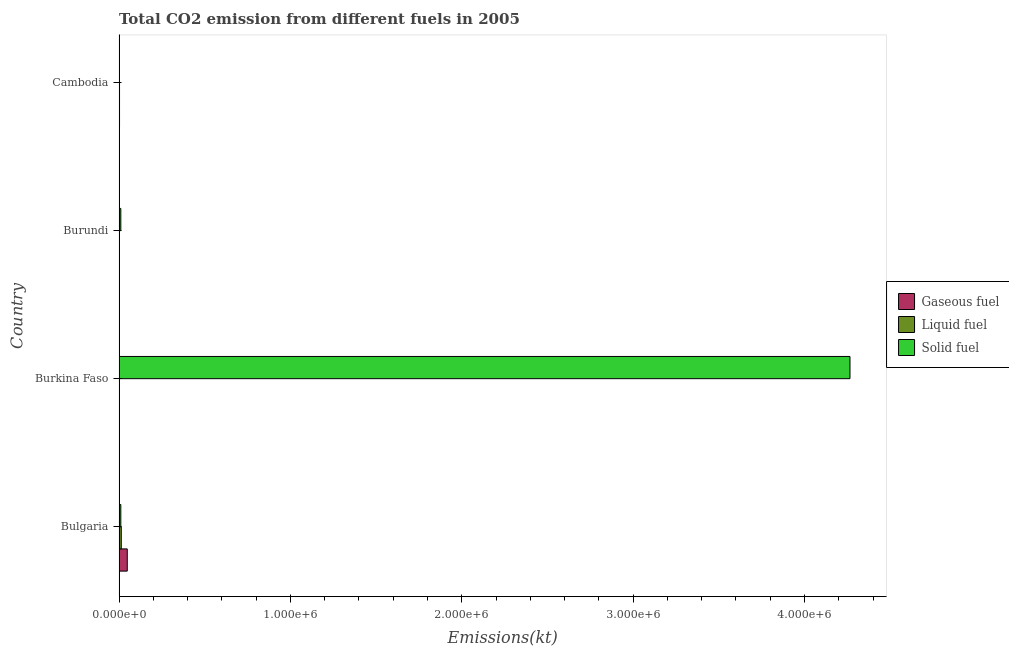How many groups of bars are there?
Your answer should be compact. 4. Are the number of bars per tick equal to the number of legend labels?
Offer a terse response. Yes. Are the number of bars on each tick of the Y-axis equal?
Your response must be concise. Yes. What is the label of the 3rd group of bars from the top?
Provide a short and direct response. Burkina Faso. What is the amount of co2 emissions from liquid fuel in Burundi?
Provide a short and direct response. 146.68. Across all countries, what is the maximum amount of co2 emissions from liquid fuel?
Make the answer very short. 1.29e+04. Across all countries, what is the minimum amount of co2 emissions from solid fuel?
Keep it short and to the point. 986.42. In which country was the amount of co2 emissions from liquid fuel maximum?
Keep it short and to the point. Bulgaria. In which country was the amount of co2 emissions from solid fuel minimum?
Ensure brevity in your answer.  Cambodia. What is the total amount of co2 emissions from gaseous fuel in the graph?
Your answer should be compact. 5.20e+04. What is the difference between the amount of co2 emissions from liquid fuel in Burundi and that in Cambodia?
Keep it short and to the point. -2629.24. What is the difference between the amount of co2 emissions from solid fuel in Burkina Faso and the amount of co2 emissions from gaseous fuel in Cambodia?
Provide a short and direct response. 4.26e+06. What is the average amount of co2 emissions from gaseous fuel per country?
Your answer should be very brief. 1.30e+04. What is the difference between the amount of co2 emissions from liquid fuel and amount of co2 emissions from solid fuel in Cambodia?
Ensure brevity in your answer.  1789.5. In how many countries, is the amount of co2 emissions from solid fuel greater than 2400000 kt?
Your answer should be compact. 1. What is the ratio of the amount of co2 emissions from liquid fuel in Burkina Faso to that in Burundi?
Your response must be concise. 7.58. Is the amount of co2 emissions from gaseous fuel in Bulgaria less than that in Burkina Faso?
Provide a succinct answer. No. Is the difference between the amount of co2 emissions from solid fuel in Burkina Faso and Burundi greater than the difference between the amount of co2 emissions from liquid fuel in Burkina Faso and Burundi?
Your answer should be very brief. Yes. What is the difference between the highest and the second highest amount of co2 emissions from liquid fuel?
Provide a short and direct response. 1.02e+04. What is the difference between the highest and the lowest amount of co2 emissions from solid fuel?
Provide a short and direct response. 4.26e+06. In how many countries, is the amount of co2 emissions from liquid fuel greater than the average amount of co2 emissions from liquid fuel taken over all countries?
Provide a succinct answer. 1. What does the 1st bar from the top in Burundi represents?
Your answer should be very brief. Solid fuel. What does the 1st bar from the bottom in Burkina Faso represents?
Keep it short and to the point. Gaseous fuel. Is it the case that in every country, the sum of the amount of co2 emissions from gaseous fuel and amount of co2 emissions from liquid fuel is greater than the amount of co2 emissions from solid fuel?
Ensure brevity in your answer.  No. How many bars are there?
Give a very brief answer. 12. Are all the bars in the graph horizontal?
Ensure brevity in your answer.  Yes. How many countries are there in the graph?
Provide a short and direct response. 4. What is the difference between two consecutive major ticks on the X-axis?
Ensure brevity in your answer.  1.00e+06. Are the values on the major ticks of X-axis written in scientific E-notation?
Your answer should be very brief. Yes. Where does the legend appear in the graph?
Provide a short and direct response. Center right. How many legend labels are there?
Your answer should be very brief. 3. What is the title of the graph?
Your answer should be very brief. Total CO2 emission from different fuels in 2005. Does "Ages 50+" appear as one of the legend labels in the graph?
Offer a terse response. No. What is the label or title of the X-axis?
Your response must be concise. Emissions(kt). What is the label or title of the Y-axis?
Your answer should be compact. Country. What is the Emissions(kt) of Gaseous fuel in Bulgaria?
Your response must be concise. 4.79e+04. What is the Emissions(kt) in Liquid fuel in Bulgaria?
Make the answer very short. 1.29e+04. What is the Emissions(kt) in Solid fuel in Bulgaria?
Provide a short and direct response. 1.03e+04. What is the Emissions(kt) of Gaseous fuel in Burkina Faso?
Your answer should be very brief. 1125.77. What is the Emissions(kt) in Liquid fuel in Burkina Faso?
Give a very brief answer. 1111.1. What is the Emissions(kt) of Solid fuel in Burkina Faso?
Provide a succinct answer. 4.27e+06. What is the Emissions(kt) in Gaseous fuel in Burundi?
Offer a very short reply. 154.01. What is the Emissions(kt) of Liquid fuel in Burundi?
Keep it short and to the point. 146.68. What is the Emissions(kt) in Solid fuel in Burundi?
Offer a terse response. 1.02e+04. What is the Emissions(kt) of Gaseous fuel in Cambodia?
Ensure brevity in your answer.  2775.92. What is the Emissions(kt) in Liquid fuel in Cambodia?
Your answer should be very brief. 2775.92. What is the Emissions(kt) in Solid fuel in Cambodia?
Offer a very short reply. 986.42. Across all countries, what is the maximum Emissions(kt) of Gaseous fuel?
Make the answer very short. 4.79e+04. Across all countries, what is the maximum Emissions(kt) of Liquid fuel?
Your response must be concise. 1.29e+04. Across all countries, what is the maximum Emissions(kt) in Solid fuel?
Your response must be concise. 4.27e+06. Across all countries, what is the minimum Emissions(kt) of Gaseous fuel?
Provide a short and direct response. 154.01. Across all countries, what is the minimum Emissions(kt) in Liquid fuel?
Provide a succinct answer. 146.68. Across all countries, what is the minimum Emissions(kt) of Solid fuel?
Your response must be concise. 986.42. What is the total Emissions(kt) of Gaseous fuel in the graph?
Keep it short and to the point. 5.20e+04. What is the total Emissions(kt) of Liquid fuel in the graph?
Provide a short and direct response. 1.70e+04. What is the total Emissions(kt) in Solid fuel in the graph?
Ensure brevity in your answer.  4.29e+06. What is the difference between the Emissions(kt) in Gaseous fuel in Bulgaria and that in Burkina Faso?
Provide a succinct answer. 4.68e+04. What is the difference between the Emissions(kt) in Liquid fuel in Bulgaria and that in Burkina Faso?
Make the answer very short. 1.18e+04. What is the difference between the Emissions(kt) in Solid fuel in Bulgaria and that in Burkina Faso?
Your response must be concise. -4.26e+06. What is the difference between the Emissions(kt) in Gaseous fuel in Bulgaria and that in Burundi?
Provide a succinct answer. 4.78e+04. What is the difference between the Emissions(kt) of Liquid fuel in Bulgaria and that in Burundi?
Your answer should be compact. 1.28e+04. What is the difference between the Emissions(kt) of Solid fuel in Bulgaria and that in Burundi?
Your answer should be very brief. 18.34. What is the difference between the Emissions(kt) of Gaseous fuel in Bulgaria and that in Cambodia?
Your answer should be compact. 4.51e+04. What is the difference between the Emissions(kt) in Liquid fuel in Bulgaria and that in Cambodia?
Keep it short and to the point. 1.02e+04. What is the difference between the Emissions(kt) in Solid fuel in Bulgaria and that in Cambodia?
Ensure brevity in your answer.  9273.84. What is the difference between the Emissions(kt) in Gaseous fuel in Burkina Faso and that in Burundi?
Offer a very short reply. 971.75. What is the difference between the Emissions(kt) of Liquid fuel in Burkina Faso and that in Burundi?
Your answer should be very brief. 964.42. What is the difference between the Emissions(kt) in Solid fuel in Burkina Faso and that in Burundi?
Your answer should be compact. 4.26e+06. What is the difference between the Emissions(kt) of Gaseous fuel in Burkina Faso and that in Cambodia?
Your answer should be compact. -1650.15. What is the difference between the Emissions(kt) of Liquid fuel in Burkina Faso and that in Cambodia?
Your answer should be very brief. -1664.82. What is the difference between the Emissions(kt) of Solid fuel in Burkina Faso and that in Cambodia?
Ensure brevity in your answer.  4.26e+06. What is the difference between the Emissions(kt) of Gaseous fuel in Burundi and that in Cambodia?
Your answer should be very brief. -2621.91. What is the difference between the Emissions(kt) in Liquid fuel in Burundi and that in Cambodia?
Offer a terse response. -2629.24. What is the difference between the Emissions(kt) in Solid fuel in Burundi and that in Cambodia?
Give a very brief answer. 9255.51. What is the difference between the Emissions(kt) in Gaseous fuel in Bulgaria and the Emissions(kt) in Liquid fuel in Burkina Faso?
Provide a short and direct response. 4.68e+04. What is the difference between the Emissions(kt) in Gaseous fuel in Bulgaria and the Emissions(kt) in Solid fuel in Burkina Faso?
Your answer should be compact. -4.22e+06. What is the difference between the Emissions(kt) of Liquid fuel in Bulgaria and the Emissions(kt) of Solid fuel in Burkina Faso?
Ensure brevity in your answer.  -4.25e+06. What is the difference between the Emissions(kt) of Gaseous fuel in Bulgaria and the Emissions(kt) of Liquid fuel in Burundi?
Offer a terse response. 4.78e+04. What is the difference between the Emissions(kt) in Gaseous fuel in Bulgaria and the Emissions(kt) in Solid fuel in Burundi?
Provide a succinct answer. 3.77e+04. What is the difference between the Emissions(kt) of Liquid fuel in Bulgaria and the Emissions(kt) of Solid fuel in Burundi?
Keep it short and to the point. 2687.91. What is the difference between the Emissions(kt) of Gaseous fuel in Bulgaria and the Emissions(kt) of Liquid fuel in Cambodia?
Your answer should be very brief. 4.51e+04. What is the difference between the Emissions(kt) in Gaseous fuel in Bulgaria and the Emissions(kt) in Solid fuel in Cambodia?
Ensure brevity in your answer.  4.69e+04. What is the difference between the Emissions(kt) in Liquid fuel in Bulgaria and the Emissions(kt) in Solid fuel in Cambodia?
Offer a terse response. 1.19e+04. What is the difference between the Emissions(kt) of Gaseous fuel in Burkina Faso and the Emissions(kt) of Liquid fuel in Burundi?
Keep it short and to the point. 979.09. What is the difference between the Emissions(kt) of Gaseous fuel in Burkina Faso and the Emissions(kt) of Solid fuel in Burundi?
Give a very brief answer. -9116.16. What is the difference between the Emissions(kt) in Liquid fuel in Burkina Faso and the Emissions(kt) in Solid fuel in Burundi?
Offer a very short reply. -9130.83. What is the difference between the Emissions(kt) of Gaseous fuel in Burkina Faso and the Emissions(kt) of Liquid fuel in Cambodia?
Your answer should be very brief. -1650.15. What is the difference between the Emissions(kt) in Gaseous fuel in Burkina Faso and the Emissions(kt) in Solid fuel in Cambodia?
Give a very brief answer. 139.35. What is the difference between the Emissions(kt) in Liquid fuel in Burkina Faso and the Emissions(kt) in Solid fuel in Cambodia?
Offer a very short reply. 124.68. What is the difference between the Emissions(kt) of Gaseous fuel in Burundi and the Emissions(kt) of Liquid fuel in Cambodia?
Provide a short and direct response. -2621.91. What is the difference between the Emissions(kt) of Gaseous fuel in Burundi and the Emissions(kt) of Solid fuel in Cambodia?
Make the answer very short. -832.41. What is the difference between the Emissions(kt) of Liquid fuel in Burundi and the Emissions(kt) of Solid fuel in Cambodia?
Keep it short and to the point. -839.74. What is the average Emissions(kt) in Gaseous fuel per country?
Offer a terse response. 1.30e+04. What is the average Emissions(kt) of Liquid fuel per country?
Ensure brevity in your answer.  4240.89. What is the average Emissions(kt) of Solid fuel per country?
Make the answer very short. 1.07e+06. What is the difference between the Emissions(kt) in Gaseous fuel and Emissions(kt) in Liquid fuel in Bulgaria?
Keep it short and to the point. 3.50e+04. What is the difference between the Emissions(kt) in Gaseous fuel and Emissions(kt) in Solid fuel in Bulgaria?
Your response must be concise. 3.76e+04. What is the difference between the Emissions(kt) of Liquid fuel and Emissions(kt) of Solid fuel in Bulgaria?
Offer a very short reply. 2669.58. What is the difference between the Emissions(kt) of Gaseous fuel and Emissions(kt) of Liquid fuel in Burkina Faso?
Your answer should be compact. 14.67. What is the difference between the Emissions(kt) in Gaseous fuel and Emissions(kt) in Solid fuel in Burkina Faso?
Offer a terse response. -4.26e+06. What is the difference between the Emissions(kt) in Liquid fuel and Emissions(kt) in Solid fuel in Burkina Faso?
Give a very brief answer. -4.26e+06. What is the difference between the Emissions(kt) in Gaseous fuel and Emissions(kt) in Liquid fuel in Burundi?
Your answer should be compact. 7.33. What is the difference between the Emissions(kt) in Gaseous fuel and Emissions(kt) in Solid fuel in Burundi?
Keep it short and to the point. -1.01e+04. What is the difference between the Emissions(kt) in Liquid fuel and Emissions(kt) in Solid fuel in Burundi?
Keep it short and to the point. -1.01e+04. What is the difference between the Emissions(kt) of Gaseous fuel and Emissions(kt) of Solid fuel in Cambodia?
Offer a very short reply. 1789.5. What is the difference between the Emissions(kt) in Liquid fuel and Emissions(kt) in Solid fuel in Cambodia?
Keep it short and to the point. 1789.5. What is the ratio of the Emissions(kt) of Gaseous fuel in Bulgaria to that in Burkina Faso?
Make the answer very short. 42.56. What is the ratio of the Emissions(kt) of Liquid fuel in Bulgaria to that in Burkina Faso?
Your answer should be compact. 11.64. What is the ratio of the Emissions(kt) in Solid fuel in Bulgaria to that in Burkina Faso?
Make the answer very short. 0. What is the ratio of the Emissions(kt) of Gaseous fuel in Bulgaria to that in Burundi?
Ensure brevity in your answer.  311.07. What is the ratio of the Emissions(kt) in Liquid fuel in Bulgaria to that in Burundi?
Your answer should be very brief. 88.15. What is the ratio of the Emissions(kt) of Gaseous fuel in Bulgaria to that in Cambodia?
Make the answer very short. 17.26. What is the ratio of the Emissions(kt) of Liquid fuel in Bulgaria to that in Cambodia?
Offer a terse response. 4.66. What is the ratio of the Emissions(kt) in Solid fuel in Bulgaria to that in Cambodia?
Your answer should be very brief. 10.4. What is the ratio of the Emissions(kt) in Gaseous fuel in Burkina Faso to that in Burundi?
Keep it short and to the point. 7.31. What is the ratio of the Emissions(kt) of Liquid fuel in Burkina Faso to that in Burundi?
Your answer should be compact. 7.58. What is the ratio of the Emissions(kt) of Solid fuel in Burkina Faso to that in Burundi?
Ensure brevity in your answer.  416.5. What is the ratio of the Emissions(kt) of Gaseous fuel in Burkina Faso to that in Cambodia?
Your answer should be compact. 0.41. What is the ratio of the Emissions(kt) in Liquid fuel in Burkina Faso to that in Cambodia?
Offer a very short reply. 0.4. What is the ratio of the Emissions(kt) in Solid fuel in Burkina Faso to that in Cambodia?
Provide a short and direct response. 4324.44. What is the ratio of the Emissions(kt) in Gaseous fuel in Burundi to that in Cambodia?
Offer a very short reply. 0.06. What is the ratio of the Emissions(kt) of Liquid fuel in Burundi to that in Cambodia?
Provide a succinct answer. 0.05. What is the ratio of the Emissions(kt) in Solid fuel in Burundi to that in Cambodia?
Ensure brevity in your answer.  10.38. What is the difference between the highest and the second highest Emissions(kt) of Gaseous fuel?
Give a very brief answer. 4.51e+04. What is the difference between the highest and the second highest Emissions(kt) in Liquid fuel?
Ensure brevity in your answer.  1.02e+04. What is the difference between the highest and the second highest Emissions(kt) in Solid fuel?
Provide a short and direct response. 4.26e+06. What is the difference between the highest and the lowest Emissions(kt) in Gaseous fuel?
Provide a succinct answer. 4.78e+04. What is the difference between the highest and the lowest Emissions(kt) of Liquid fuel?
Your answer should be compact. 1.28e+04. What is the difference between the highest and the lowest Emissions(kt) of Solid fuel?
Keep it short and to the point. 4.26e+06. 